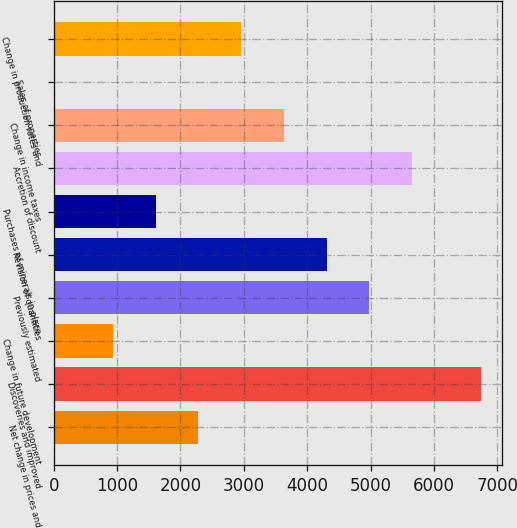Convert chart to OTSL. <chart><loc_0><loc_0><loc_500><loc_500><bar_chart><fcel>Net change in prices and<fcel>Discoveries and improved<fcel>Change in future development<fcel>Previously estimated<fcel>Revision of quantities<fcel>Purchases of minerals in-place<fcel>Accretion of discount<fcel>Change in income taxes<fcel>Sales of properties<fcel>Change in production rates and<nl><fcel>2282.8<fcel>6742<fcel>935<fcel>4978.4<fcel>4304.5<fcel>1608.9<fcel>5652.3<fcel>3630.6<fcel>3<fcel>2956.7<nl></chart> 